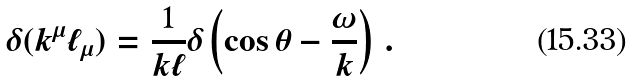Convert formula to latex. <formula><loc_0><loc_0><loc_500><loc_500>\delta ( k ^ { \mu } \ell _ { \mu } ) = \frac { 1 } { k \ell } \delta \left ( \cos \theta - \frac { \omega } { k } \right ) \, .</formula> 